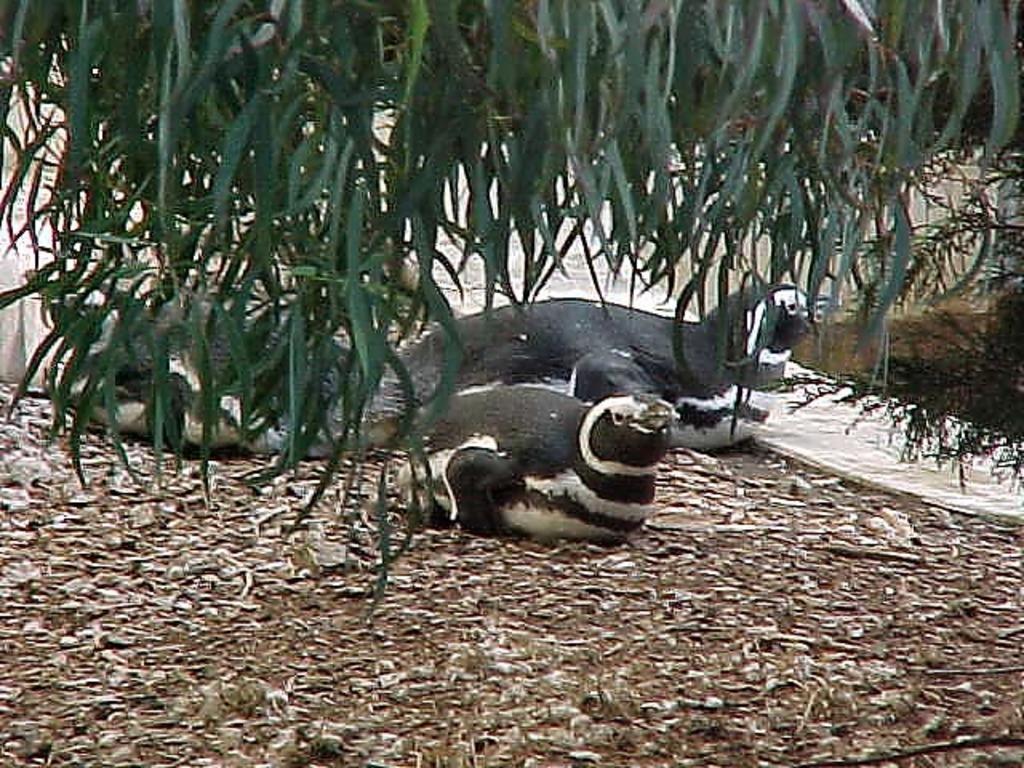In one or two sentences, can you explain what this image depicts? In this image we can see animals on the ground. At the top of the image we can see leaves. 